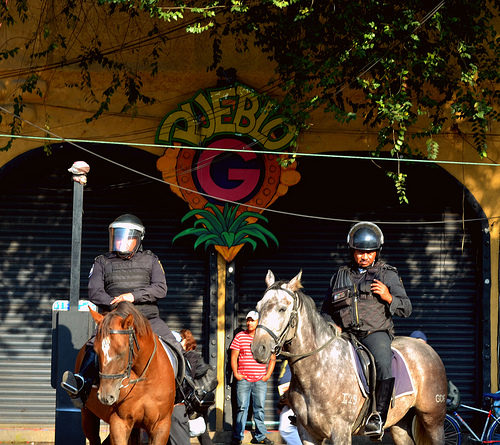What can you tell me about the setting behind the horses? The image shows a closed storefront with shutters down. Above it is a brightly colored sign with 'QUEBIO G'. It suggests a commercial area, likely captured during a moment when the businesses are closed. 